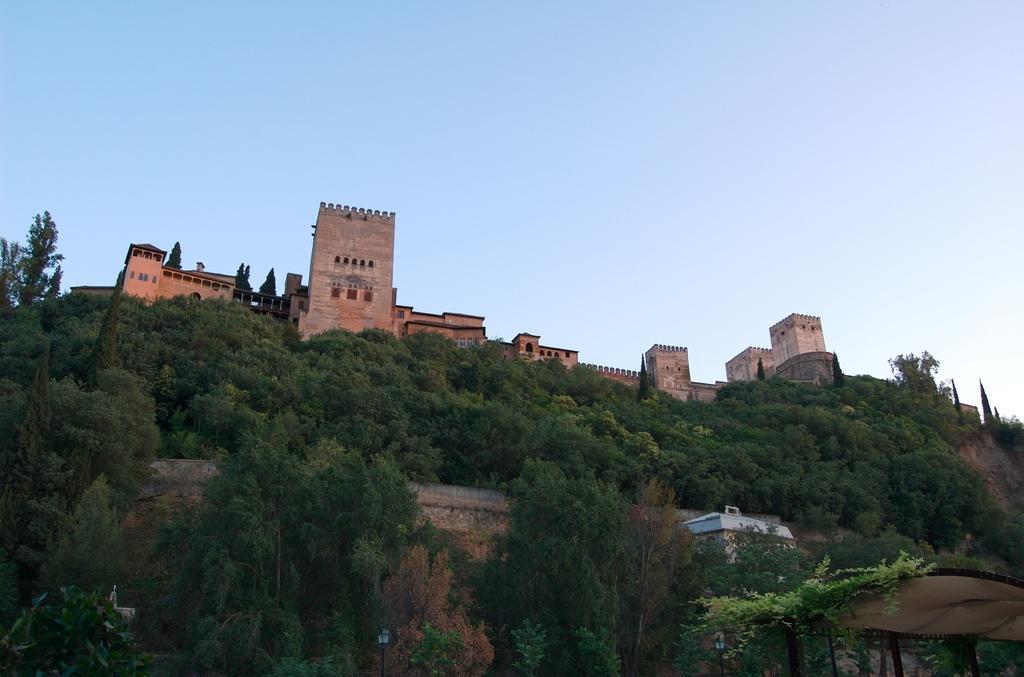How would you summarize this image in a sentence or two? In this image we can see a fort. There are many trees. In the background there is sky. Also there are few other buildings. 